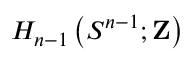Convert formula to latex. <formula><loc_0><loc_0><loc_500><loc_500>H _ { n - 1 } \left ( S ^ { n - 1 } ; Z \right )</formula> 